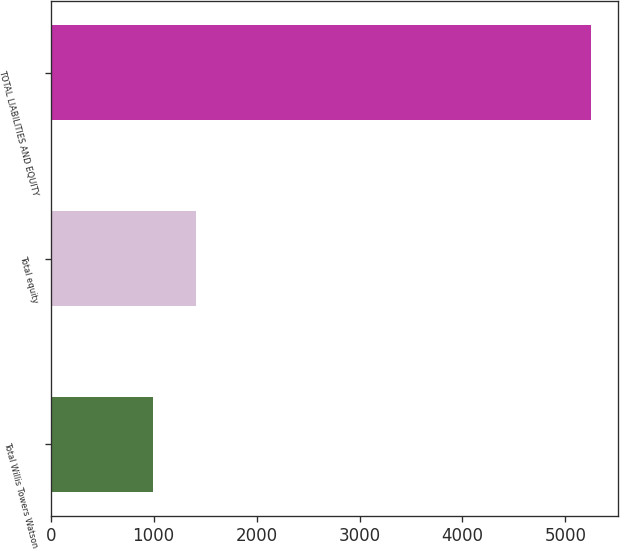Convert chart to OTSL. <chart><loc_0><loc_0><loc_500><loc_500><bar_chart><fcel>Total Willis Towers Watson<fcel>Total equity<fcel>TOTAL LIABILITIES AND EQUITY<nl><fcel>989<fcel>1415.3<fcel>5252<nl></chart> 